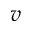<formula> <loc_0><loc_0><loc_500><loc_500>v</formula> 